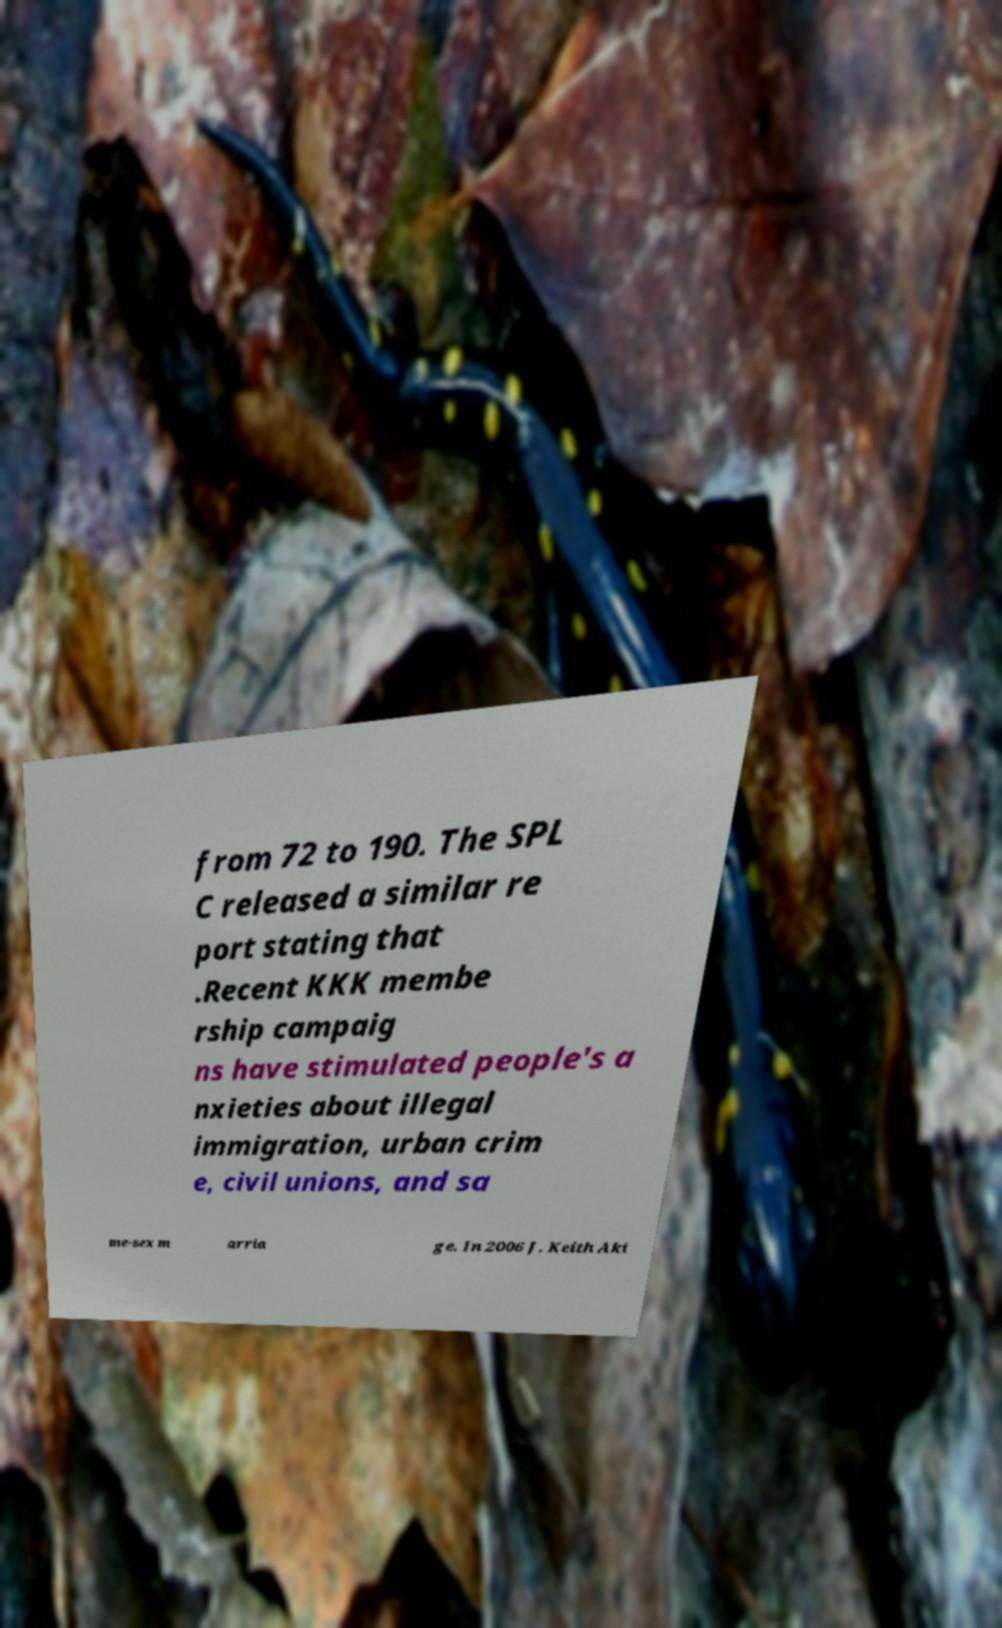Please identify and transcribe the text found in this image. from 72 to 190. The SPL C released a similar re port stating that .Recent KKK membe rship campaig ns have stimulated people's a nxieties about illegal immigration, urban crim e, civil unions, and sa me-sex m arria ge. In 2006 J. Keith Aki 